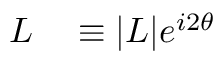<formula> <loc_0><loc_0><loc_500><loc_500>\begin{array} { r l } { L } & \equiv | L | e ^ { i 2 \theta } } \end{array}</formula> 